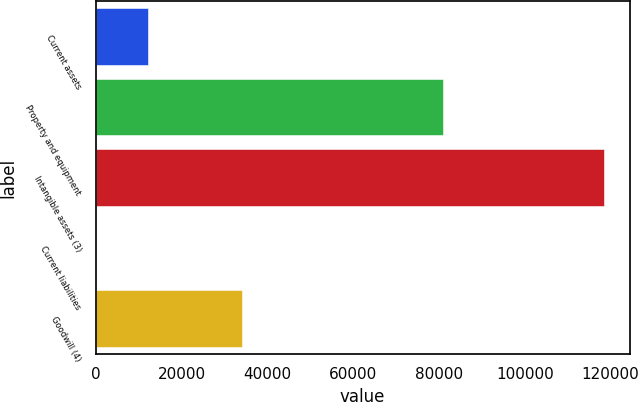Convert chart to OTSL. <chart><loc_0><loc_0><loc_500><loc_500><bar_chart><fcel>Current assets<fcel>Property and equipment<fcel>Intangible assets (3)<fcel>Current liabilities<fcel>Goodwill (4)<nl><fcel>12262<fcel>81052<fcel>118502<fcel>74<fcel>34159<nl></chart> 